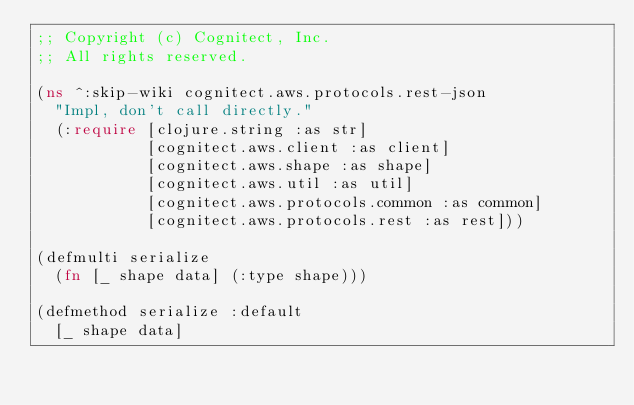Convert code to text. <code><loc_0><loc_0><loc_500><loc_500><_Clojure_>;; Copyright (c) Cognitect, Inc.
;; All rights reserved.

(ns ^:skip-wiki cognitect.aws.protocols.rest-json
  "Impl, don't call directly."
  (:require [clojure.string :as str]
            [cognitect.aws.client :as client]
            [cognitect.aws.shape :as shape]
            [cognitect.aws.util :as util]
            [cognitect.aws.protocols.common :as common]
            [cognitect.aws.protocols.rest :as rest]))

(defmulti serialize
  (fn [_ shape data] (:type shape)))

(defmethod serialize :default
  [_ shape data]</code> 